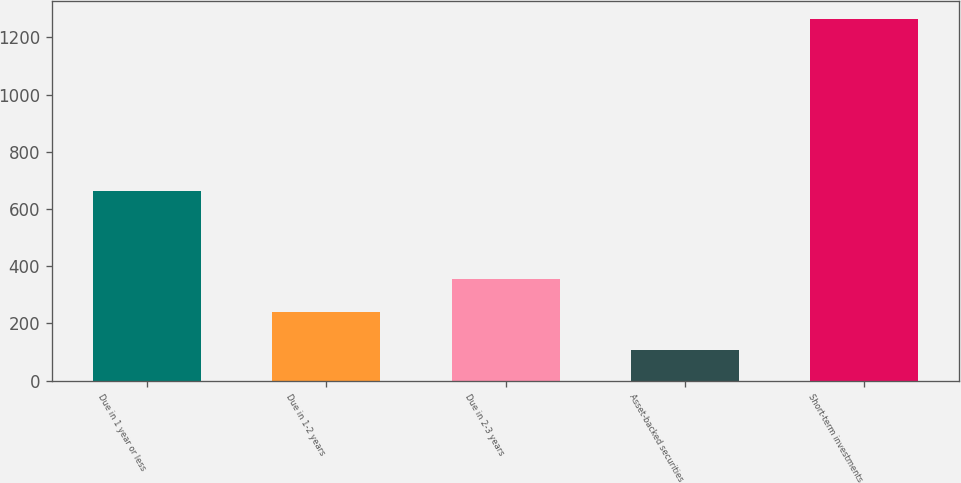Convert chart to OTSL. <chart><loc_0><loc_0><loc_500><loc_500><bar_chart><fcel>Due in 1 year or less<fcel>Due in 1-2 years<fcel>Due in 2-3 years<fcel>Asset-backed securities<fcel>Short-term investments<nl><fcel>662<fcel>241<fcel>356.6<fcel>107<fcel>1263<nl></chart> 